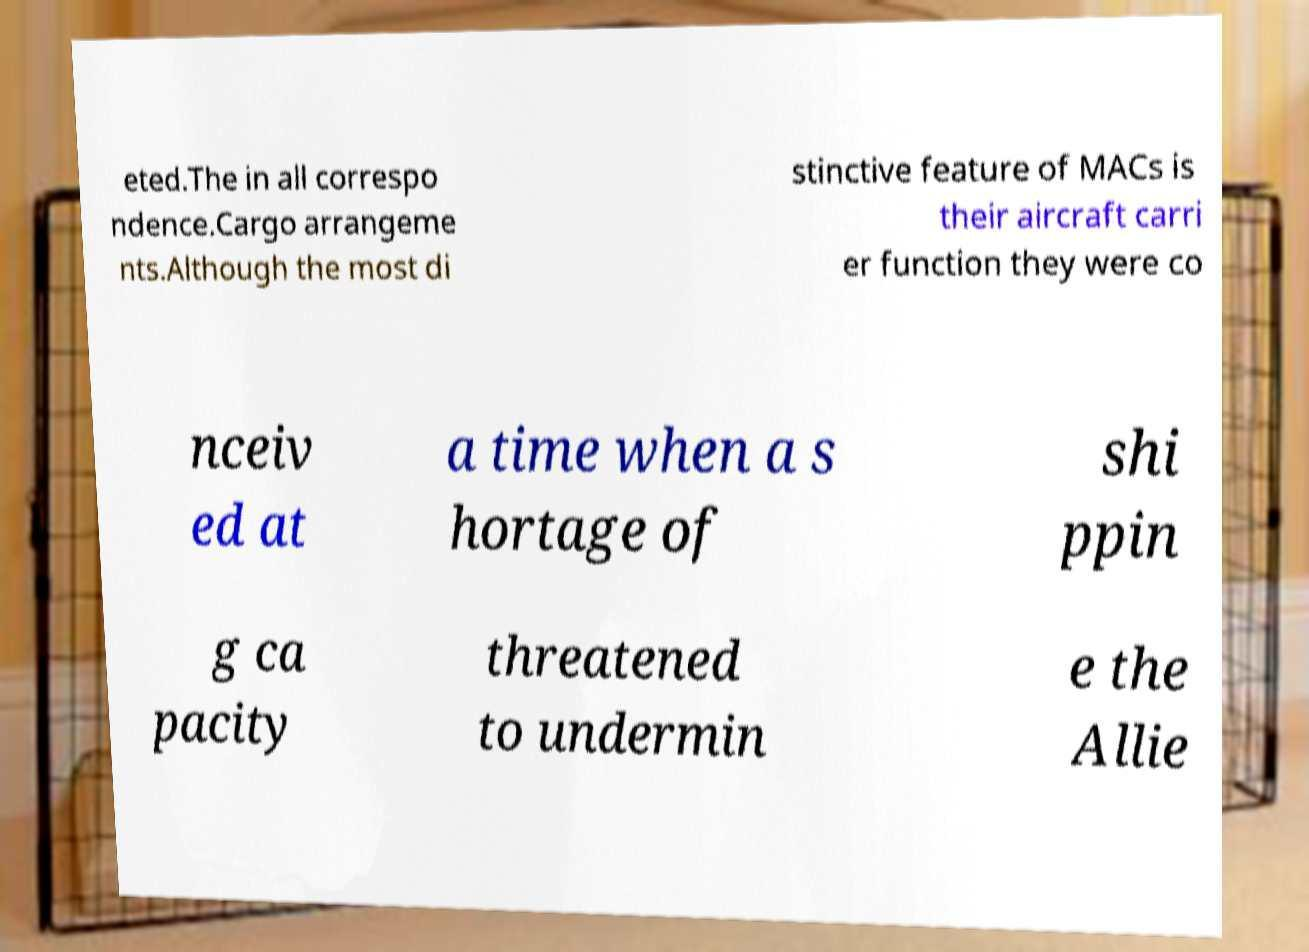Could you extract and type out the text from this image? eted.The in all correspo ndence.Cargo arrangeme nts.Although the most di stinctive feature of MACs is their aircraft carri er function they were co nceiv ed at a time when a s hortage of shi ppin g ca pacity threatened to undermin e the Allie 